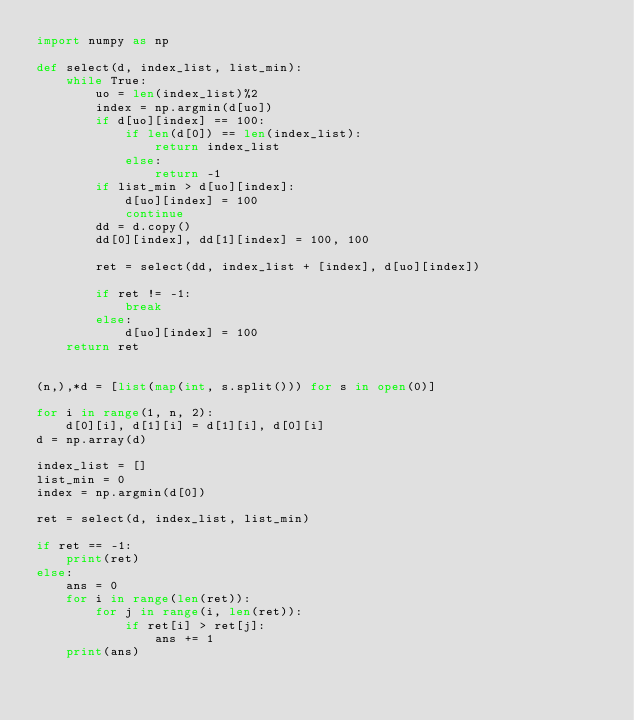<code> <loc_0><loc_0><loc_500><loc_500><_Python_>import numpy as np

def select(d, index_list, list_min):
    while True:
        uo = len(index_list)%2
        index = np.argmin(d[uo])
        if d[uo][index] == 100:
            if len(d[0]) == len(index_list):
                return index_list
            else:
                return -1
        if list_min > d[uo][index]:
            d[uo][index] = 100
            continue
        dd = d.copy()
        dd[0][index], dd[1][index] = 100, 100

        ret = select(dd, index_list + [index], d[uo][index])

        if ret != -1:
            break
        else:
            d[uo][index] = 100
    return ret
        

(n,),*d = [list(map(int, s.split())) for s in open(0)]

for i in range(1, n, 2):
    d[0][i], d[1][i] = d[1][i], d[0][i]
d = np.array(d)

index_list = []
list_min = 0
index = np.argmin(d[0])

ret = select(d, index_list, list_min)

if ret == -1:
    print(ret)
else:
    ans = 0
    for i in range(len(ret)):
        for j in range(i, len(ret)):
            if ret[i] > ret[j]:
                ans += 1
    print(ans)</code> 